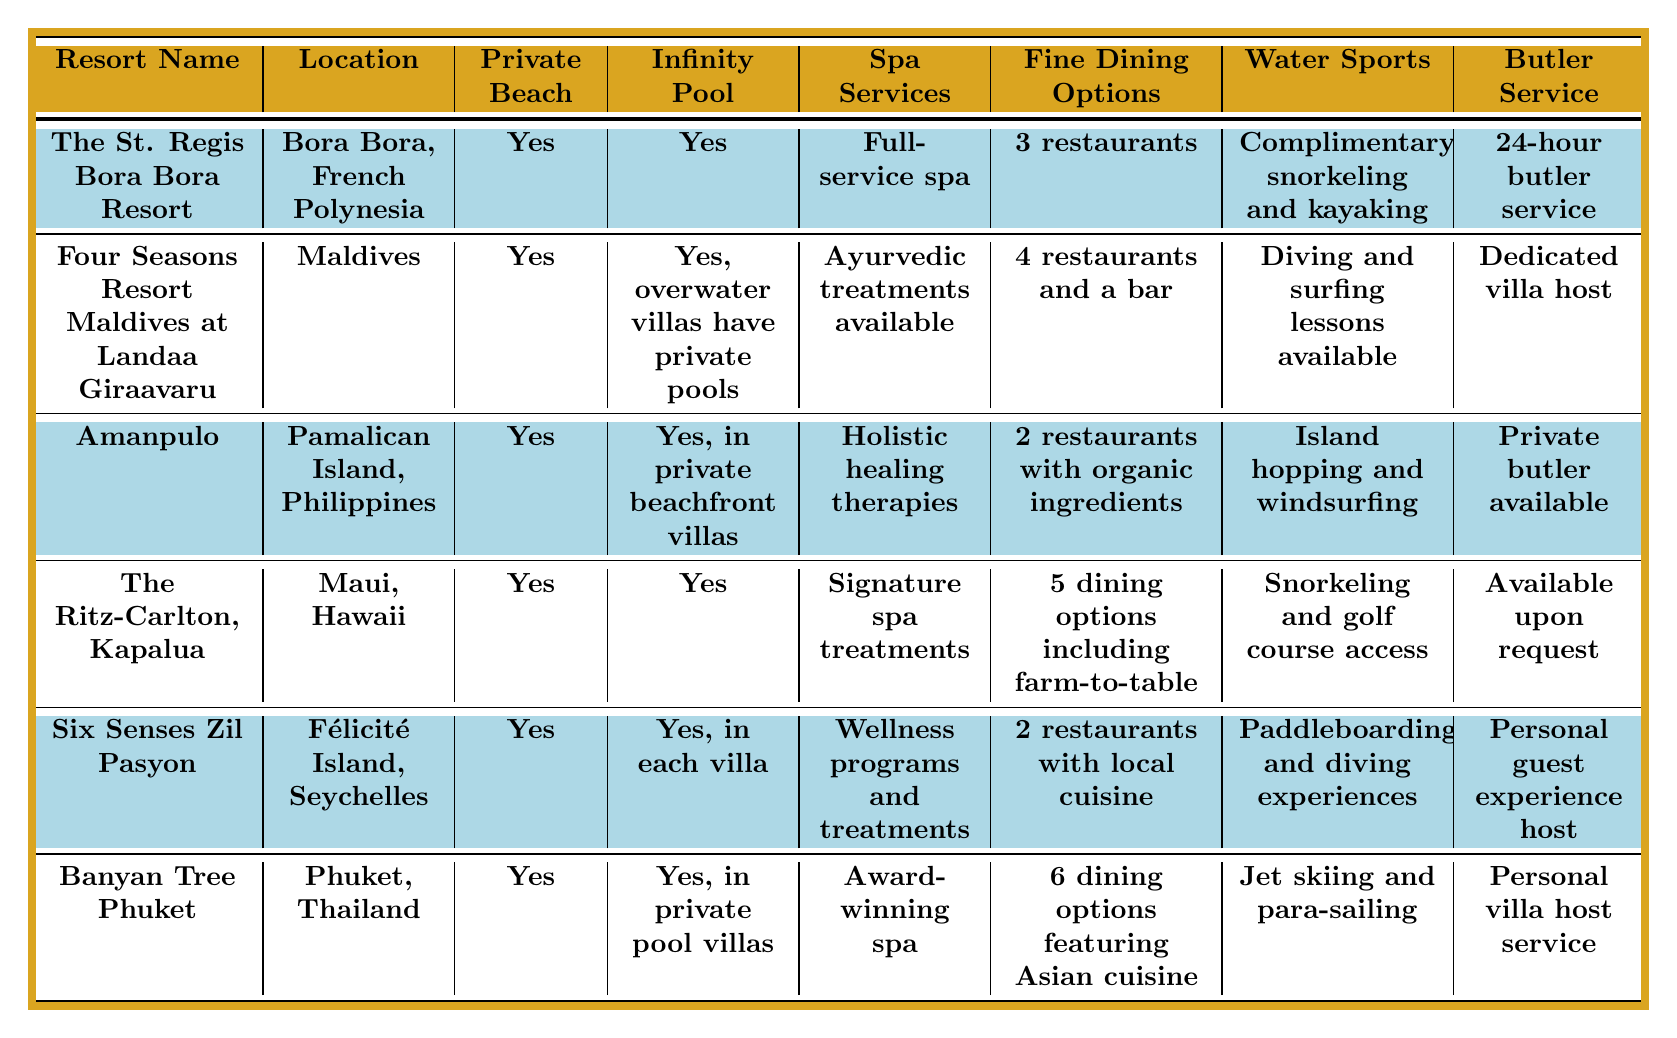What resorts offer a private beach? By reviewing the "Private Beach" column in the table, all listed resorts have their private beach amenities marked as "Yes".
Answer: Yes How many dining options does The Ritz-Carlton, Kapalua offer? The "Fine Dining Options" column for The Ritz-Carlton, Kapalua specifies that there are 5 dining options including farm-to-table.
Answer: 5 Which resort has a dedicated butler service? In the "Butler Service" column, both The St. Regis Bora Bora Resort and Amanpulo have a form of dedicated butler service, specified as "24-hour butler service" and "Private butler available" respectively.
Answer: The St. Regis Bora Bora Resort and Amanpulo Which resort has the most fine dining options? Comparing the "Fine Dining Options" from each resort, Banyan Tree Phuket has 6 options, which is the highest.
Answer: Banyan Tree Phuket Is there a resort in the table that offers complimentary water sports? Checking the "Water Sports" column, The St. Regis Bora Bora Resort offers "Complimentary snorkeling and kayaking" which verifies that there is indeed a resort offering complimentary activities.
Answer: Yes How many resorts offer wellness-related spa services? By analyzing the "Spa Services" column, The Ritz-Carlton, Kapalua, Six Senses Zil Pasyon, and Banyan Tree Phuket all provide wellness-related services, totaling 3 resorts.
Answer: 3 Which resort has the unique feature of having private pools in overwater villas? In the "Infinity Pool" column, Four Seasons Resort Maldives is specifically noted with "Yes, overwater villas have private pools".
Answer: Four Seasons Resort Maldives at Landaa Giraavaru Which location has the least number of fine dining options among these resorts? Looking at the "Fine Dining Options", Amanpulo has the least with 2 restaurants.
Answer: Amanpulo What is the difference in the number of restaurants between Four Seasons Resort Maldives and Banyan Tree Phuket? Four Seasons Resort Maldives has 4 dining options, while Banyan Tree Phuket has 6. Therefore, the difference is 6 - 4 = 2.
Answer: 2 Which resort has both an infinity pool and spa services that focus on holistic healing? Checking both the "Infinity Pool" and "Spa Services" columns, Amanpulo meets the criteria as it states "Yes, in private beachfront villas" and "Holistic healing therapies".
Answer: Amanpulo 